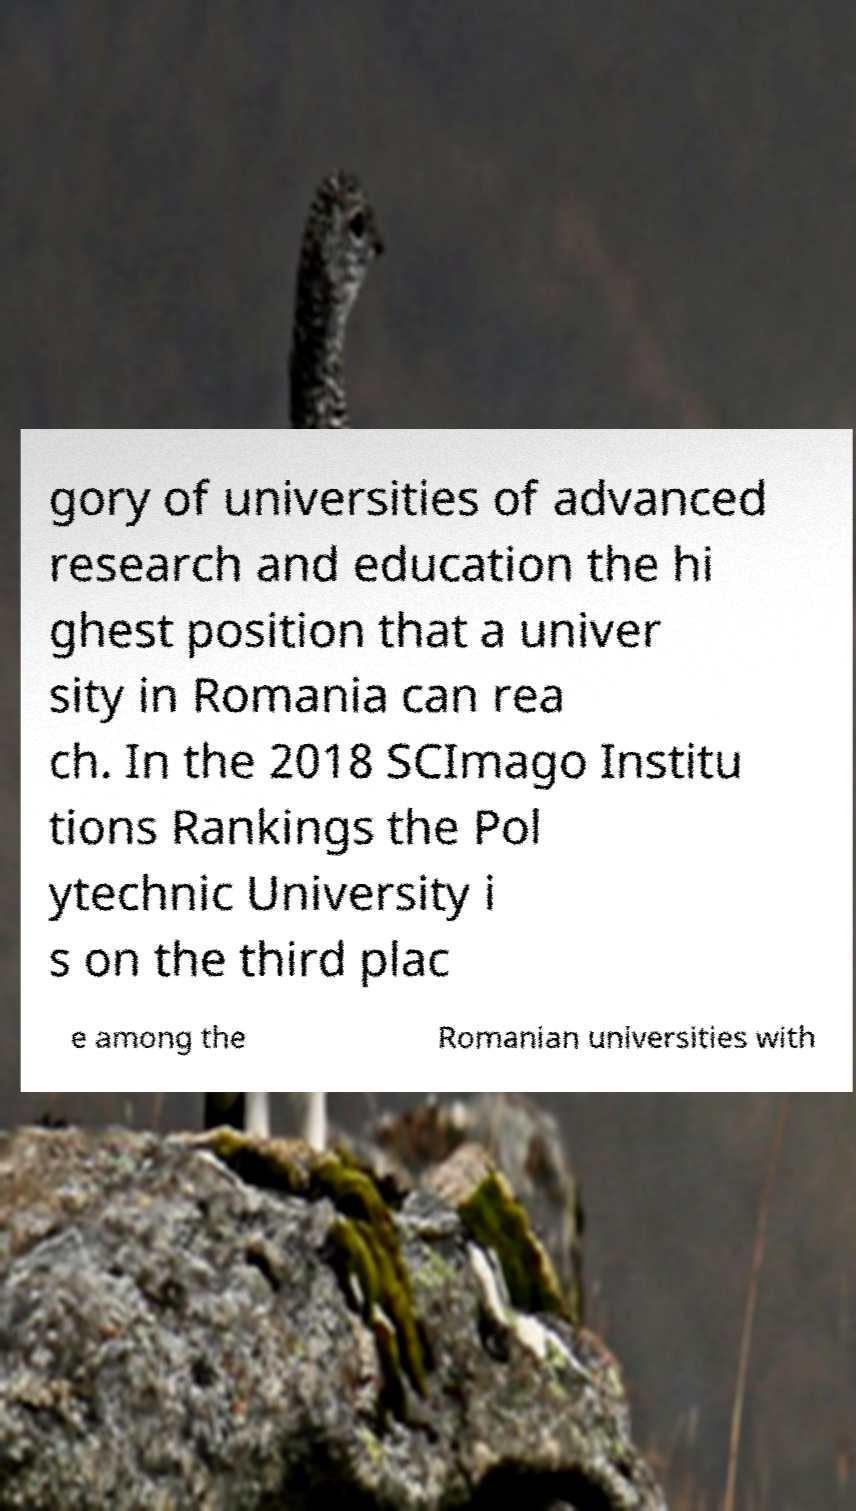Please identify and transcribe the text found in this image. gory of universities of advanced research and education the hi ghest position that a univer sity in Romania can rea ch. In the 2018 SCImago Institu tions Rankings the Pol ytechnic University i s on the third plac e among the Romanian universities with 